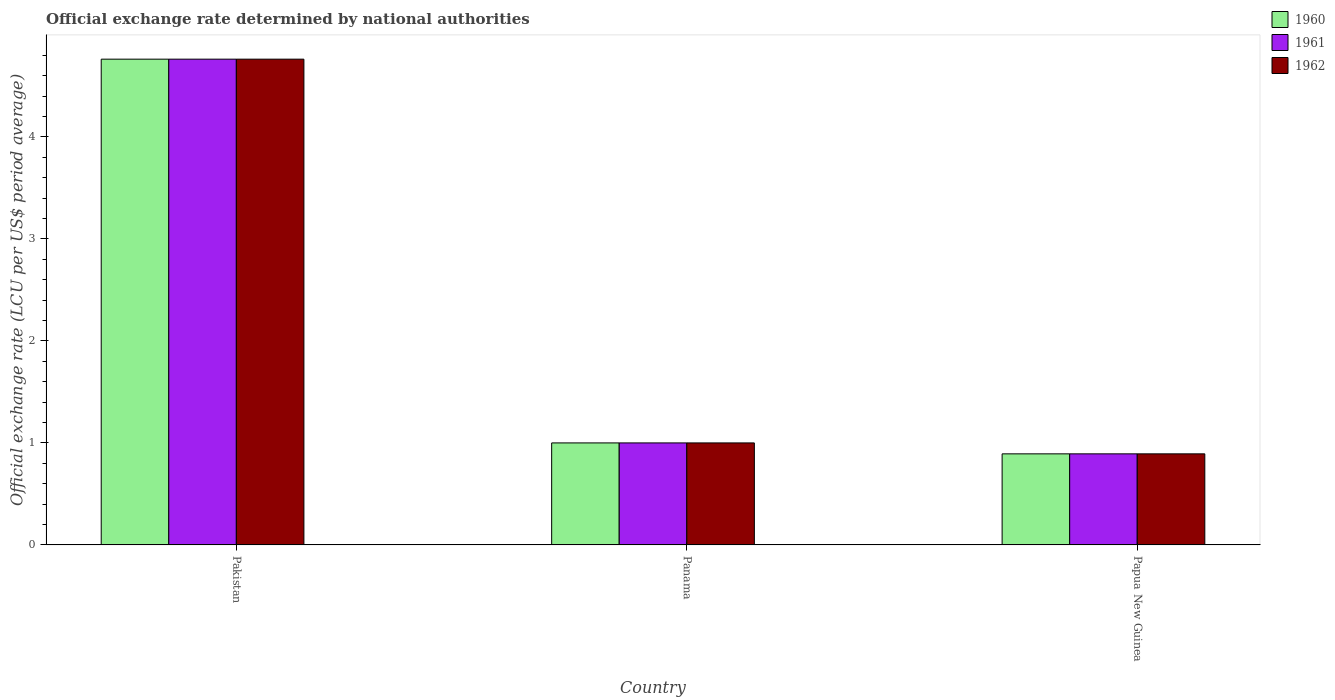How many different coloured bars are there?
Your response must be concise. 3. How many groups of bars are there?
Provide a succinct answer. 3. Are the number of bars on each tick of the X-axis equal?
Offer a terse response. Yes. How many bars are there on the 3rd tick from the right?
Your response must be concise. 3. What is the label of the 3rd group of bars from the left?
Give a very brief answer. Papua New Guinea. Across all countries, what is the maximum official exchange rate in 1960?
Your answer should be compact. 4.76. Across all countries, what is the minimum official exchange rate in 1960?
Your answer should be compact. 0.89. In which country was the official exchange rate in 1962 maximum?
Your answer should be compact. Pakistan. In which country was the official exchange rate in 1960 minimum?
Provide a short and direct response. Papua New Guinea. What is the total official exchange rate in 1960 in the graph?
Offer a very short reply. 6.65. What is the difference between the official exchange rate in 1960 in Pakistan and that in Panama?
Offer a very short reply. 3.76. What is the difference between the official exchange rate in 1961 in Pakistan and the official exchange rate in 1962 in Papua New Guinea?
Make the answer very short. 3.87. What is the average official exchange rate in 1961 per country?
Your answer should be compact. 2.22. What is the difference between the official exchange rate of/in 1961 and official exchange rate of/in 1960 in Pakistan?
Give a very brief answer. 0. In how many countries, is the official exchange rate in 1960 greater than 0.8 LCU?
Your answer should be very brief. 3. What is the ratio of the official exchange rate in 1962 in Pakistan to that in Papua New Guinea?
Your answer should be very brief. 5.33. What is the difference between the highest and the second highest official exchange rate in 1960?
Give a very brief answer. -0.11. What is the difference between the highest and the lowest official exchange rate in 1960?
Offer a terse response. 3.87. In how many countries, is the official exchange rate in 1960 greater than the average official exchange rate in 1960 taken over all countries?
Offer a terse response. 1. What does the 3rd bar from the right in Panama represents?
Ensure brevity in your answer.  1960. Is it the case that in every country, the sum of the official exchange rate in 1961 and official exchange rate in 1962 is greater than the official exchange rate in 1960?
Provide a short and direct response. Yes. Are all the bars in the graph horizontal?
Ensure brevity in your answer.  No. Are the values on the major ticks of Y-axis written in scientific E-notation?
Give a very brief answer. No. Does the graph contain any zero values?
Offer a very short reply. No. Where does the legend appear in the graph?
Your response must be concise. Top right. How many legend labels are there?
Make the answer very short. 3. How are the legend labels stacked?
Provide a succinct answer. Vertical. What is the title of the graph?
Offer a terse response. Official exchange rate determined by national authorities. What is the label or title of the X-axis?
Keep it short and to the point. Country. What is the label or title of the Y-axis?
Give a very brief answer. Official exchange rate (LCU per US$ period average). What is the Official exchange rate (LCU per US$ period average) in 1960 in Pakistan?
Keep it short and to the point. 4.76. What is the Official exchange rate (LCU per US$ period average) in 1961 in Pakistan?
Your answer should be compact. 4.76. What is the Official exchange rate (LCU per US$ period average) in 1962 in Pakistan?
Make the answer very short. 4.76. What is the Official exchange rate (LCU per US$ period average) in 1960 in Panama?
Your response must be concise. 1. What is the Official exchange rate (LCU per US$ period average) of 1961 in Panama?
Keep it short and to the point. 1. What is the Official exchange rate (LCU per US$ period average) in 1962 in Panama?
Provide a short and direct response. 1. What is the Official exchange rate (LCU per US$ period average) of 1960 in Papua New Guinea?
Your answer should be very brief. 0.89. What is the Official exchange rate (LCU per US$ period average) in 1961 in Papua New Guinea?
Your answer should be very brief. 0.89. What is the Official exchange rate (LCU per US$ period average) in 1962 in Papua New Guinea?
Your response must be concise. 0.89. Across all countries, what is the maximum Official exchange rate (LCU per US$ period average) of 1960?
Offer a very short reply. 4.76. Across all countries, what is the maximum Official exchange rate (LCU per US$ period average) in 1961?
Provide a succinct answer. 4.76. Across all countries, what is the maximum Official exchange rate (LCU per US$ period average) in 1962?
Offer a very short reply. 4.76. Across all countries, what is the minimum Official exchange rate (LCU per US$ period average) in 1960?
Your response must be concise. 0.89. Across all countries, what is the minimum Official exchange rate (LCU per US$ period average) of 1961?
Provide a succinct answer. 0.89. Across all countries, what is the minimum Official exchange rate (LCU per US$ period average) in 1962?
Offer a terse response. 0.89. What is the total Official exchange rate (LCU per US$ period average) of 1960 in the graph?
Provide a succinct answer. 6.65. What is the total Official exchange rate (LCU per US$ period average) of 1961 in the graph?
Provide a short and direct response. 6.65. What is the total Official exchange rate (LCU per US$ period average) of 1962 in the graph?
Your answer should be very brief. 6.65. What is the difference between the Official exchange rate (LCU per US$ period average) of 1960 in Pakistan and that in Panama?
Your answer should be compact. 3.76. What is the difference between the Official exchange rate (LCU per US$ period average) in 1961 in Pakistan and that in Panama?
Your answer should be very brief. 3.76. What is the difference between the Official exchange rate (LCU per US$ period average) of 1962 in Pakistan and that in Panama?
Give a very brief answer. 3.76. What is the difference between the Official exchange rate (LCU per US$ period average) in 1960 in Pakistan and that in Papua New Guinea?
Give a very brief answer. 3.87. What is the difference between the Official exchange rate (LCU per US$ period average) in 1961 in Pakistan and that in Papua New Guinea?
Give a very brief answer. 3.87. What is the difference between the Official exchange rate (LCU per US$ period average) in 1962 in Pakistan and that in Papua New Guinea?
Give a very brief answer. 3.87. What is the difference between the Official exchange rate (LCU per US$ period average) of 1960 in Panama and that in Papua New Guinea?
Your answer should be very brief. 0.11. What is the difference between the Official exchange rate (LCU per US$ period average) in 1961 in Panama and that in Papua New Guinea?
Ensure brevity in your answer.  0.11. What is the difference between the Official exchange rate (LCU per US$ period average) of 1962 in Panama and that in Papua New Guinea?
Give a very brief answer. 0.11. What is the difference between the Official exchange rate (LCU per US$ period average) in 1960 in Pakistan and the Official exchange rate (LCU per US$ period average) in 1961 in Panama?
Your answer should be very brief. 3.76. What is the difference between the Official exchange rate (LCU per US$ period average) of 1960 in Pakistan and the Official exchange rate (LCU per US$ period average) of 1962 in Panama?
Offer a very short reply. 3.76. What is the difference between the Official exchange rate (LCU per US$ period average) of 1961 in Pakistan and the Official exchange rate (LCU per US$ period average) of 1962 in Panama?
Provide a succinct answer. 3.76. What is the difference between the Official exchange rate (LCU per US$ period average) in 1960 in Pakistan and the Official exchange rate (LCU per US$ period average) in 1961 in Papua New Guinea?
Provide a succinct answer. 3.87. What is the difference between the Official exchange rate (LCU per US$ period average) in 1960 in Pakistan and the Official exchange rate (LCU per US$ period average) in 1962 in Papua New Guinea?
Give a very brief answer. 3.87. What is the difference between the Official exchange rate (LCU per US$ period average) in 1961 in Pakistan and the Official exchange rate (LCU per US$ period average) in 1962 in Papua New Guinea?
Provide a succinct answer. 3.87. What is the difference between the Official exchange rate (LCU per US$ period average) of 1960 in Panama and the Official exchange rate (LCU per US$ period average) of 1961 in Papua New Guinea?
Offer a very short reply. 0.11. What is the difference between the Official exchange rate (LCU per US$ period average) in 1960 in Panama and the Official exchange rate (LCU per US$ period average) in 1962 in Papua New Guinea?
Make the answer very short. 0.11. What is the difference between the Official exchange rate (LCU per US$ period average) of 1961 in Panama and the Official exchange rate (LCU per US$ period average) of 1962 in Papua New Guinea?
Offer a very short reply. 0.11. What is the average Official exchange rate (LCU per US$ period average) in 1960 per country?
Ensure brevity in your answer.  2.22. What is the average Official exchange rate (LCU per US$ period average) of 1961 per country?
Ensure brevity in your answer.  2.22. What is the average Official exchange rate (LCU per US$ period average) of 1962 per country?
Offer a terse response. 2.22. What is the difference between the Official exchange rate (LCU per US$ period average) of 1960 and Official exchange rate (LCU per US$ period average) of 1962 in Pakistan?
Provide a short and direct response. 0. What is the difference between the Official exchange rate (LCU per US$ period average) of 1961 and Official exchange rate (LCU per US$ period average) of 1962 in Panama?
Keep it short and to the point. 0. What is the difference between the Official exchange rate (LCU per US$ period average) in 1961 and Official exchange rate (LCU per US$ period average) in 1962 in Papua New Guinea?
Provide a succinct answer. 0. What is the ratio of the Official exchange rate (LCU per US$ period average) of 1960 in Pakistan to that in Panama?
Provide a short and direct response. 4.76. What is the ratio of the Official exchange rate (LCU per US$ period average) of 1961 in Pakistan to that in Panama?
Provide a succinct answer. 4.76. What is the ratio of the Official exchange rate (LCU per US$ period average) of 1962 in Pakistan to that in Panama?
Offer a very short reply. 4.76. What is the ratio of the Official exchange rate (LCU per US$ period average) in 1960 in Pakistan to that in Papua New Guinea?
Offer a terse response. 5.33. What is the ratio of the Official exchange rate (LCU per US$ period average) in 1961 in Pakistan to that in Papua New Guinea?
Offer a very short reply. 5.33. What is the ratio of the Official exchange rate (LCU per US$ period average) in 1962 in Pakistan to that in Papua New Guinea?
Make the answer very short. 5.33. What is the ratio of the Official exchange rate (LCU per US$ period average) of 1960 in Panama to that in Papua New Guinea?
Your answer should be compact. 1.12. What is the ratio of the Official exchange rate (LCU per US$ period average) of 1961 in Panama to that in Papua New Guinea?
Give a very brief answer. 1.12. What is the ratio of the Official exchange rate (LCU per US$ period average) in 1962 in Panama to that in Papua New Guinea?
Offer a terse response. 1.12. What is the difference between the highest and the second highest Official exchange rate (LCU per US$ period average) of 1960?
Offer a terse response. 3.76. What is the difference between the highest and the second highest Official exchange rate (LCU per US$ period average) of 1961?
Your answer should be compact. 3.76. What is the difference between the highest and the second highest Official exchange rate (LCU per US$ period average) of 1962?
Provide a succinct answer. 3.76. What is the difference between the highest and the lowest Official exchange rate (LCU per US$ period average) of 1960?
Keep it short and to the point. 3.87. What is the difference between the highest and the lowest Official exchange rate (LCU per US$ period average) of 1961?
Keep it short and to the point. 3.87. What is the difference between the highest and the lowest Official exchange rate (LCU per US$ period average) in 1962?
Provide a succinct answer. 3.87. 